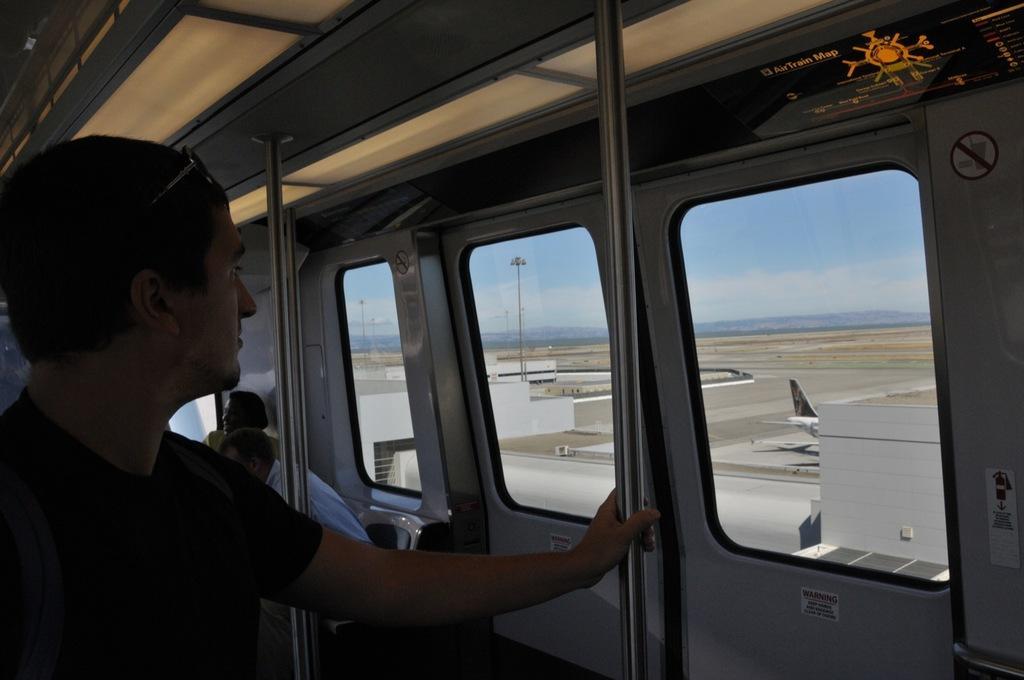Can you describe this image briefly? In this picture I can see there is a person standing here and they are some other people in the train and there is a runway here and there is a air plane here. 